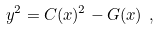<formula> <loc_0><loc_0><loc_500><loc_500>y ^ { 2 } = C ( x ) ^ { 2 } - G ( x ) \ ,</formula> 